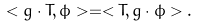Convert formula to latex. <formula><loc_0><loc_0><loc_500><loc_500>< g \cdot T , \phi > = < T , g \cdot \phi > .</formula> 